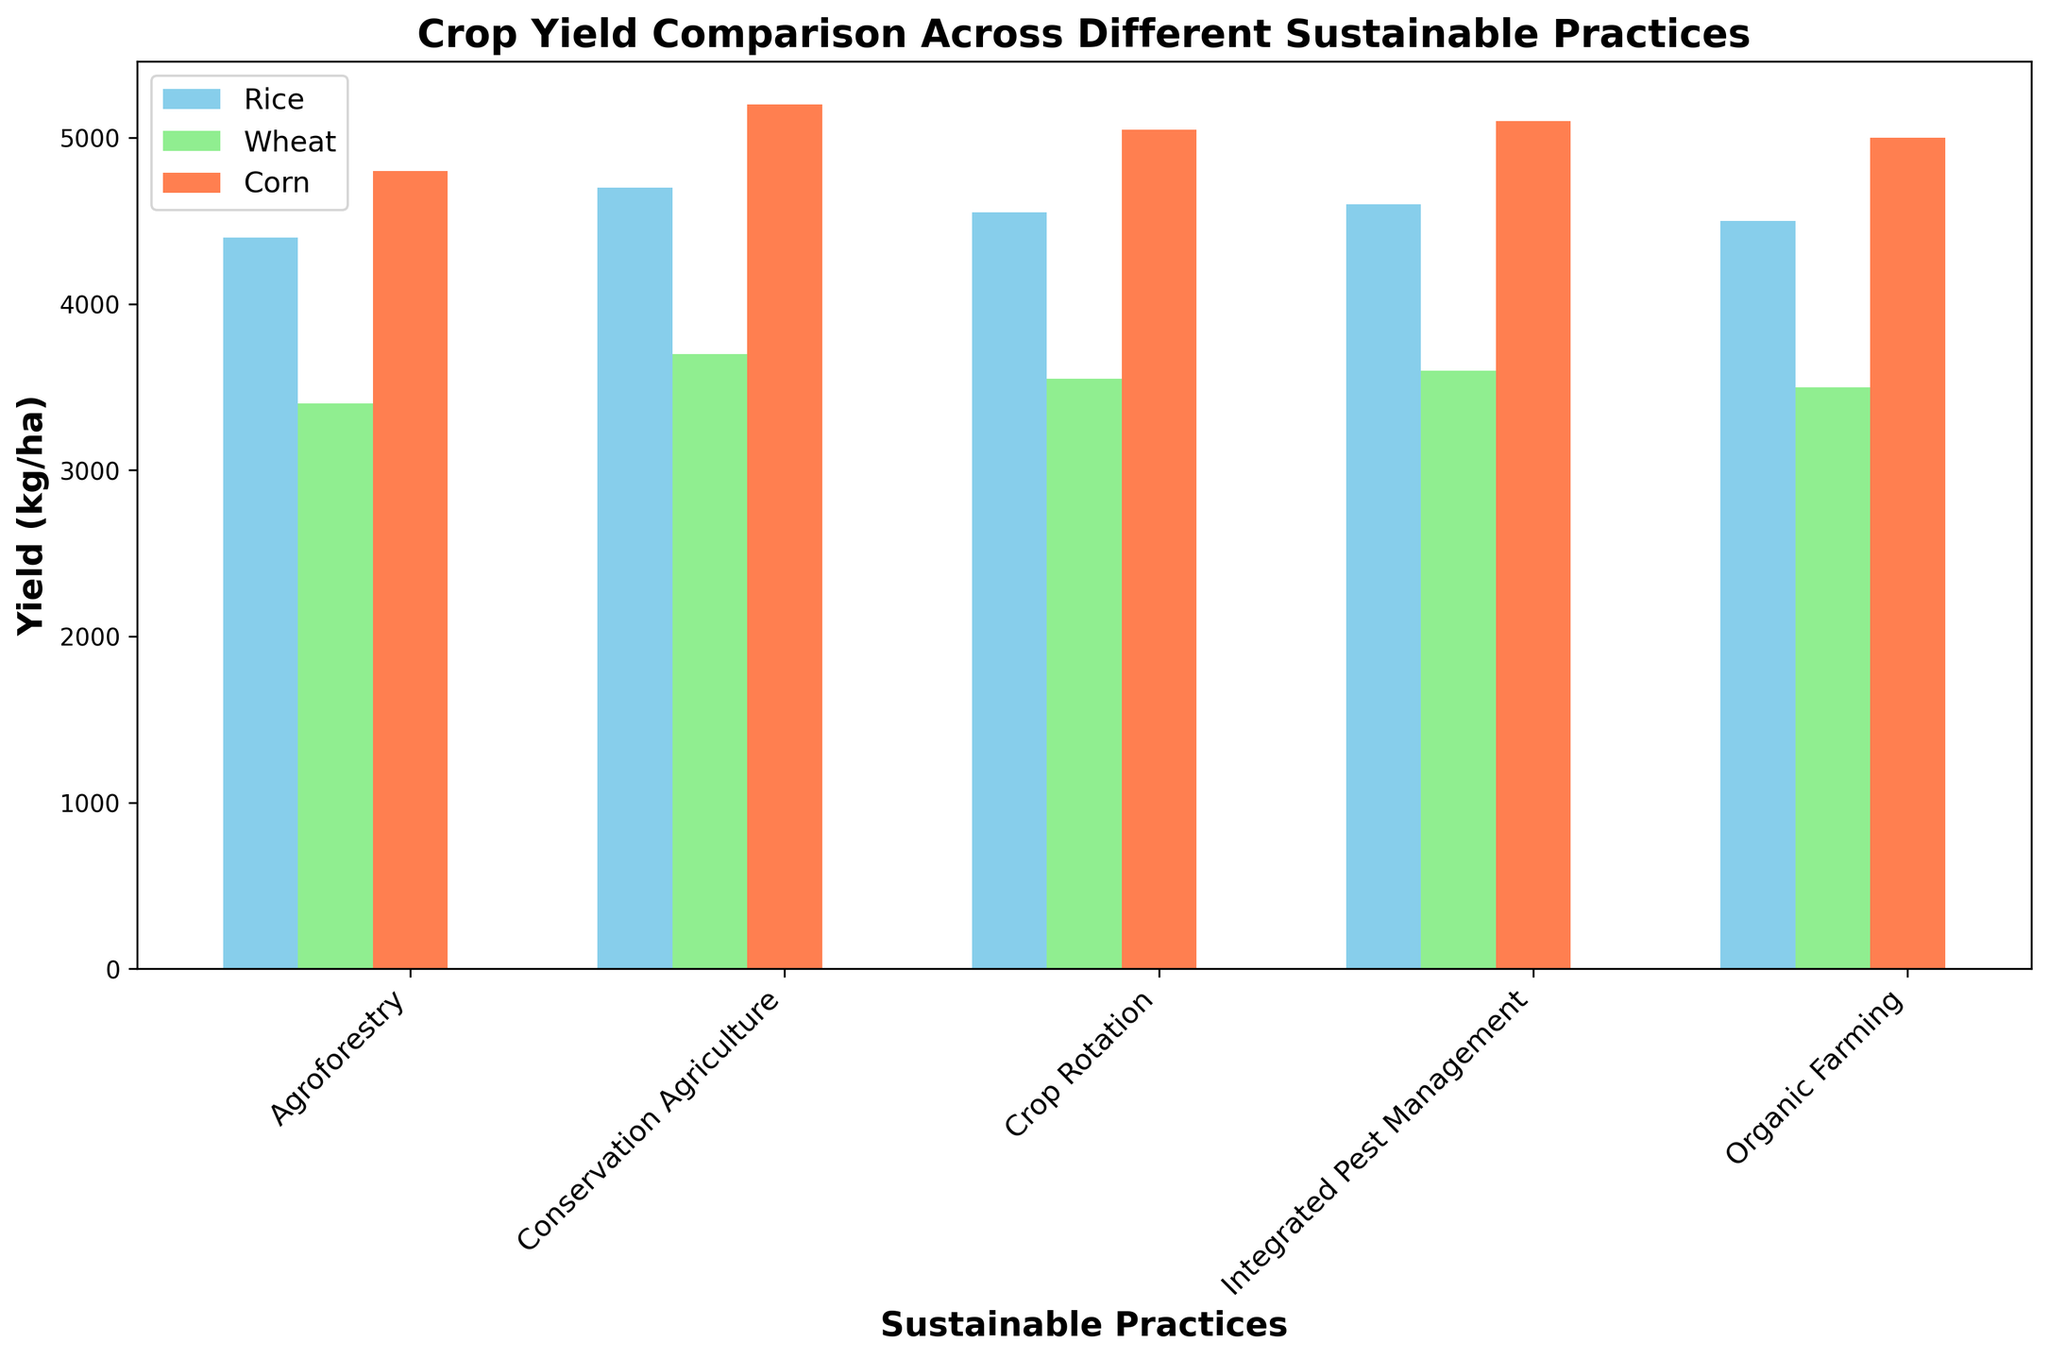What is the total yield of Wheat across all sustainable practices? Sum the yield values for Wheat: 3500 (Organic Farming) + 3700 (Conservation Agriculture) + 3400 (Agroforestry) + 3600 (Integrated Pest Management) + 3550 (Crop Rotation). The total yield is 17750 kg/ha.
Answer: 17750 Which sustainable practice has the highest yield for Corn? Compare the yields for Corn across all practices: 5000 (Organic Farming), 5200 (Conservation Agriculture), 4800 (Agroforestry), 5100 (Integrated Pest Management), 5050 (Crop Rotation). Conservation Agriculture has the highest yield of 5200 kg/ha.
Answer: Conservation Agriculture How does the yield of Rice in Agroforestry compare to Integrated Pest Management? Integrated Pest Management's yield for Rice is 4600 kg/ha, while Agroforestry's yield for Rice is 4400 kg/ha. Comparing these, Integrated Pest Management has a higher yield.
Answer: Integrated Pest Management has a higher yield Which crop has the lowest yield in Organic Farming? Compare the yields of each crop in Organic Farming: 4500 (Rice), 3500 (Wheat), 5000 (Corn). Wheat has the lowest yield of 3500 kg/ha.
Answer: Wheat What is the average yield of Corn across all sustainable practices? Calculate the average: Sum the Corn yields (5000 + 5200 + 4800 + 5100 + 5050) = 25150 kg, then divide by the number of practices (5). The average yield is 5030 kg/ha.
Answer: 5030 Is Corn yield greater in Conservation Agriculture or Crop Rotation? Compare Corn yields: Conservation Agriculture (5200 kg/ha) vs. Crop Rotation (5050 kg/ha). Conservation Agriculture has a greater yield.
Answer: Conservation Agriculture If you rank the yields of Rice in descending order across all practices, which practice comes third? Order the yields of Rice: 4700 (Conservation Agriculture), 4600 (Integrated Pest Management), 4550 (Crop Rotation), 4500 (Organic Farming), 4400 (Agroforestry). Crop Rotation comes third with a yield of 4550 kg/ha.
Answer: Crop Rotation Which sustainable practice has the most balanced yields across different crops (i.e., the smallest difference between the highest and lowest yield)? Calculate the difference between the highest and lowest yield for each practice: Organic Farming: 5000 - 3500 = 1500; Conservation Agriculture: 5200 - 3700 = 1500; Agroforestry: 4800 - 3400 = 1400; Integrated Pest Management: 5100 - 3600 = 1500; Crop Rotation: 5050 - 3550 = 1500. Agroforestry has the smallest difference of 1400 kg/ha.
Answer: Agroforestry What is the color of the bars representing Wheat yield? Identify the color used in the bar chart for Wheat yield. Each crop is represented by a different color, with Wheat in light green.
Answer: light green 